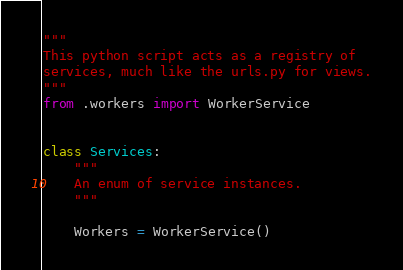Convert code to text. <code><loc_0><loc_0><loc_500><loc_500><_Python_>"""
This python script acts as a registry of
services, much like the urls.py for views.
"""
from .workers import WorkerService


class Services:
    """
    An enum of service instances.
    """

    Workers = WorkerService()
</code> 